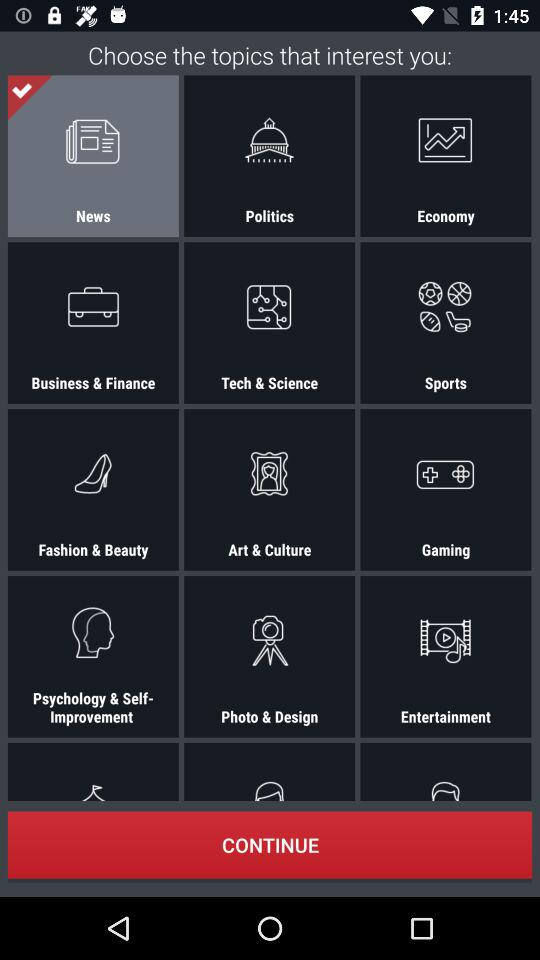Which topic is selected? The selected topic is "News". 